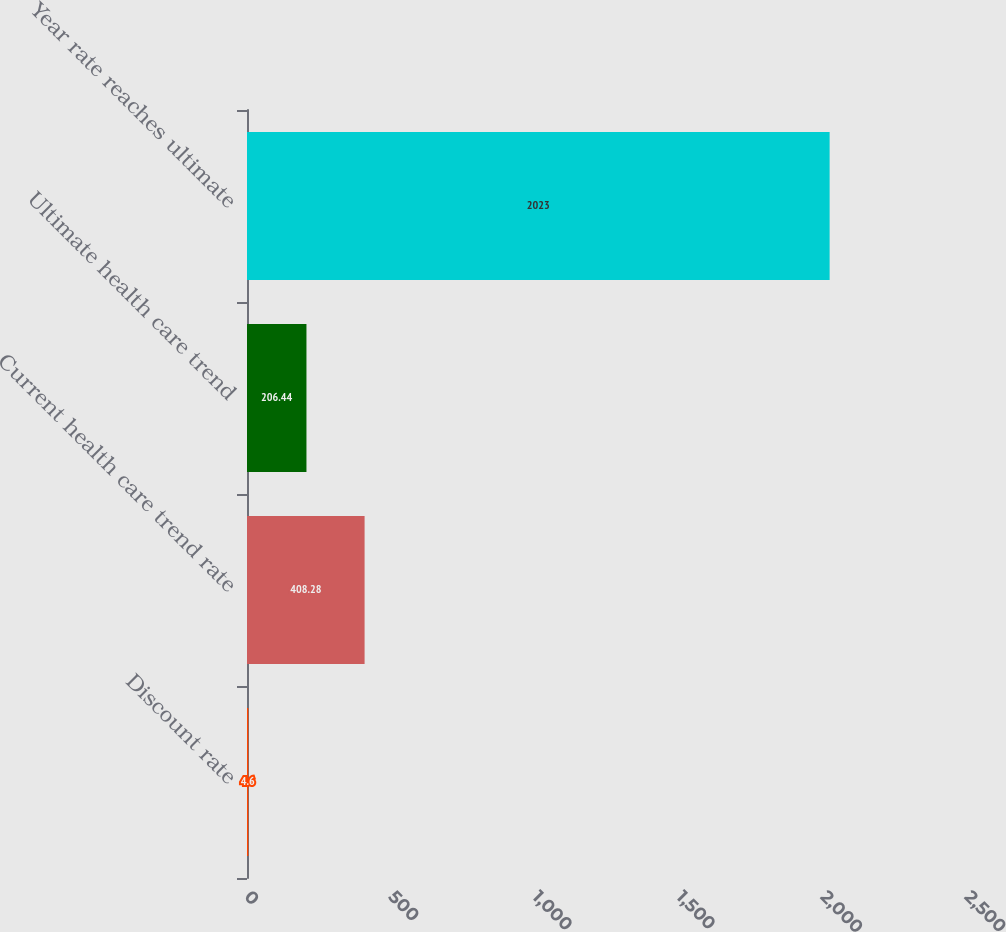Convert chart. <chart><loc_0><loc_0><loc_500><loc_500><bar_chart><fcel>Discount rate<fcel>Current health care trend rate<fcel>Ultimate health care trend<fcel>Year rate reaches ultimate<nl><fcel>4.6<fcel>408.28<fcel>206.44<fcel>2023<nl></chart> 